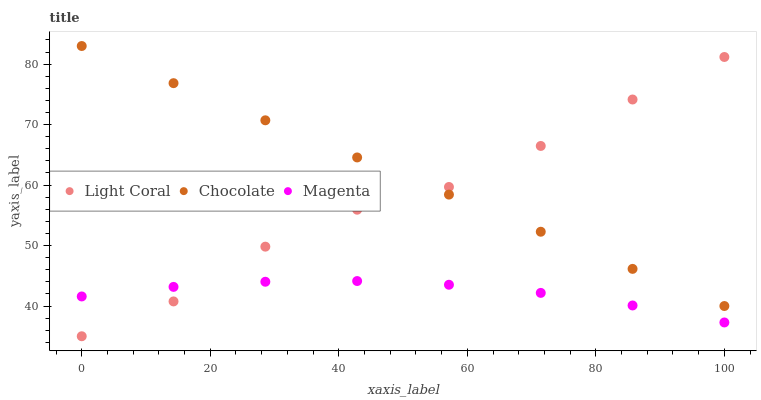Does Magenta have the minimum area under the curve?
Answer yes or no. Yes. Does Chocolate have the maximum area under the curve?
Answer yes or no. Yes. Does Chocolate have the minimum area under the curve?
Answer yes or no. No. Does Magenta have the maximum area under the curve?
Answer yes or no. No. Is Chocolate the smoothest?
Answer yes or no. Yes. Is Light Coral the roughest?
Answer yes or no. Yes. Is Magenta the smoothest?
Answer yes or no. No. Is Magenta the roughest?
Answer yes or no. No. Does Light Coral have the lowest value?
Answer yes or no. Yes. Does Magenta have the lowest value?
Answer yes or no. No. Does Chocolate have the highest value?
Answer yes or no. Yes. Does Magenta have the highest value?
Answer yes or no. No. Is Magenta less than Chocolate?
Answer yes or no. Yes. Is Chocolate greater than Magenta?
Answer yes or no. Yes. Does Chocolate intersect Light Coral?
Answer yes or no. Yes. Is Chocolate less than Light Coral?
Answer yes or no. No. Is Chocolate greater than Light Coral?
Answer yes or no. No. Does Magenta intersect Chocolate?
Answer yes or no. No. 